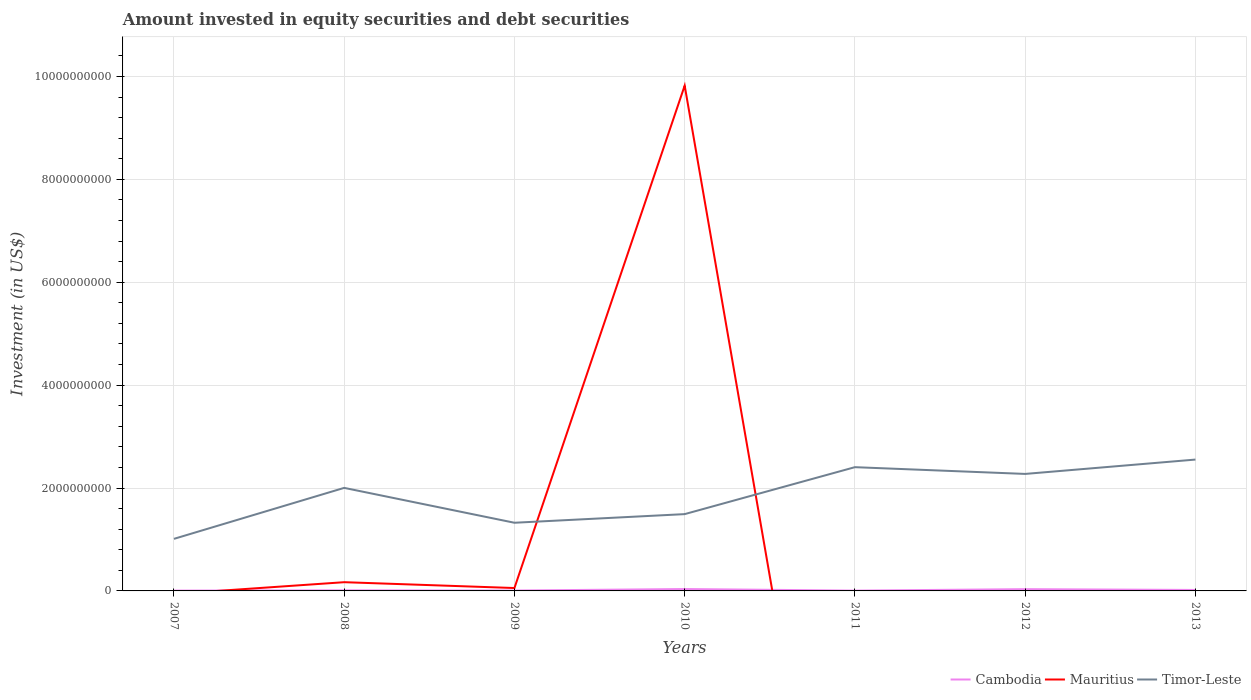Does the line corresponding to Mauritius intersect with the line corresponding to Timor-Leste?
Keep it short and to the point. Yes. Is the number of lines equal to the number of legend labels?
Ensure brevity in your answer.  No. What is the total amount invested in equity securities and debt securities in Mauritius in the graph?
Offer a very short reply. 1.13e+08. What is the difference between the highest and the second highest amount invested in equity securities and debt securities in Cambodia?
Make the answer very short. 3.05e+07. What is the difference between the highest and the lowest amount invested in equity securities and debt securities in Cambodia?
Provide a succinct answer. 3. Is the amount invested in equity securities and debt securities in Timor-Leste strictly greater than the amount invested in equity securities and debt securities in Cambodia over the years?
Your answer should be compact. No. How many lines are there?
Give a very brief answer. 3. How many years are there in the graph?
Your answer should be very brief. 7. Are the values on the major ticks of Y-axis written in scientific E-notation?
Make the answer very short. No. Where does the legend appear in the graph?
Make the answer very short. Bottom right. How many legend labels are there?
Your answer should be compact. 3. How are the legend labels stacked?
Provide a short and direct response. Horizontal. What is the title of the graph?
Your answer should be compact. Amount invested in equity securities and debt securities. What is the label or title of the X-axis?
Give a very brief answer. Years. What is the label or title of the Y-axis?
Provide a short and direct response. Investment (in US$). What is the Investment (in US$) of Cambodia in 2007?
Offer a terse response. 6.33e+06. What is the Investment (in US$) of Timor-Leste in 2007?
Offer a very short reply. 1.01e+09. What is the Investment (in US$) in Cambodia in 2008?
Provide a short and direct response. 1.16e+07. What is the Investment (in US$) of Mauritius in 2008?
Offer a very short reply. 1.70e+08. What is the Investment (in US$) in Timor-Leste in 2008?
Offer a very short reply. 2.00e+09. What is the Investment (in US$) in Cambodia in 2009?
Your answer should be very brief. 7.62e+06. What is the Investment (in US$) in Mauritius in 2009?
Offer a terse response. 5.63e+07. What is the Investment (in US$) in Timor-Leste in 2009?
Your answer should be compact. 1.33e+09. What is the Investment (in US$) in Cambodia in 2010?
Keep it short and to the point. 3.67e+07. What is the Investment (in US$) in Mauritius in 2010?
Your answer should be compact. 9.82e+09. What is the Investment (in US$) of Timor-Leste in 2010?
Ensure brevity in your answer.  1.49e+09. What is the Investment (in US$) in Cambodia in 2011?
Ensure brevity in your answer.  6.14e+06. What is the Investment (in US$) in Timor-Leste in 2011?
Offer a very short reply. 2.41e+09. What is the Investment (in US$) of Cambodia in 2012?
Ensure brevity in your answer.  3.42e+07. What is the Investment (in US$) of Mauritius in 2012?
Your answer should be very brief. 0. What is the Investment (in US$) in Timor-Leste in 2012?
Your answer should be very brief. 2.27e+09. What is the Investment (in US$) in Cambodia in 2013?
Make the answer very short. 1.88e+07. What is the Investment (in US$) of Timor-Leste in 2013?
Provide a succinct answer. 2.55e+09. Across all years, what is the maximum Investment (in US$) in Cambodia?
Your answer should be compact. 3.67e+07. Across all years, what is the maximum Investment (in US$) in Mauritius?
Provide a short and direct response. 9.82e+09. Across all years, what is the maximum Investment (in US$) in Timor-Leste?
Your answer should be very brief. 2.55e+09. Across all years, what is the minimum Investment (in US$) of Cambodia?
Ensure brevity in your answer.  6.14e+06. Across all years, what is the minimum Investment (in US$) of Mauritius?
Offer a very short reply. 0. Across all years, what is the minimum Investment (in US$) of Timor-Leste?
Give a very brief answer. 1.01e+09. What is the total Investment (in US$) of Cambodia in the graph?
Keep it short and to the point. 1.21e+08. What is the total Investment (in US$) of Mauritius in the graph?
Make the answer very short. 1.00e+1. What is the total Investment (in US$) in Timor-Leste in the graph?
Keep it short and to the point. 1.31e+1. What is the difference between the Investment (in US$) in Cambodia in 2007 and that in 2008?
Keep it short and to the point. -5.25e+06. What is the difference between the Investment (in US$) in Timor-Leste in 2007 and that in 2008?
Keep it short and to the point. -9.91e+08. What is the difference between the Investment (in US$) in Cambodia in 2007 and that in 2009?
Your answer should be very brief. -1.29e+06. What is the difference between the Investment (in US$) in Timor-Leste in 2007 and that in 2009?
Give a very brief answer. -3.13e+08. What is the difference between the Investment (in US$) of Cambodia in 2007 and that in 2010?
Offer a very short reply. -3.03e+07. What is the difference between the Investment (in US$) of Timor-Leste in 2007 and that in 2010?
Make the answer very short. -4.81e+08. What is the difference between the Investment (in US$) of Cambodia in 2007 and that in 2011?
Offer a terse response. 1.96e+05. What is the difference between the Investment (in US$) in Timor-Leste in 2007 and that in 2011?
Give a very brief answer. -1.39e+09. What is the difference between the Investment (in US$) in Cambodia in 2007 and that in 2012?
Offer a terse response. -2.78e+07. What is the difference between the Investment (in US$) of Timor-Leste in 2007 and that in 2012?
Ensure brevity in your answer.  -1.26e+09. What is the difference between the Investment (in US$) of Cambodia in 2007 and that in 2013?
Make the answer very short. -1.25e+07. What is the difference between the Investment (in US$) of Timor-Leste in 2007 and that in 2013?
Ensure brevity in your answer.  -1.54e+09. What is the difference between the Investment (in US$) of Cambodia in 2008 and that in 2009?
Make the answer very short. 3.97e+06. What is the difference between the Investment (in US$) in Mauritius in 2008 and that in 2009?
Give a very brief answer. 1.13e+08. What is the difference between the Investment (in US$) of Timor-Leste in 2008 and that in 2009?
Provide a succinct answer. 6.78e+08. What is the difference between the Investment (in US$) of Cambodia in 2008 and that in 2010?
Keep it short and to the point. -2.51e+07. What is the difference between the Investment (in US$) of Mauritius in 2008 and that in 2010?
Offer a terse response. -9.65e+09. What is the difference between the Investment (in US$) of Timor-Leste in 2008 and that in 2010?
Ensure brevity in your answer.  5.10e+08. What is the difference between the Investment (in US$) of Cambodia in 2008 and that in 2011?
Give a very brief answer. 5.45e+06. What is the difference between the Investment (in US$) in Timor-Leste in 2008 and that in 2011?
Provide a succinct answer. -4.03e+08. What is the difference between the Investment (in US$) in Cambodia in 2008 and that in 2012?
Provide a short and direct response. -2.26e+07. What is the difference between the Investment (in US$) in Timor-Leste in 2008 and that in 2012?
Keep it short and to the point. -2.71e+08. What is the difference between the Investment (in US$) of Cambodia in 2008 and that in 2013?
Make the answer very short. -7.21e+06. What is the difference between the Investment (in US$) of Timor-Leste in 2008 and that in 2013?
Offer a terse response. -5.50e+08. What is the difference between the Investment (in US$) in Cambodia in 2009 and that in 2010?
Your answer should be very brief. -2.90e+07. What is the difference between the Investment (in US$) of Mauritius in 2009 and that in 2010?
Give a very brief answer. -9.77e+09. What is the difference between the Investment (in US$) of Timor-Leste in 2009 and that in 2010?
Your answer should be very brief. -1.68e+08. What is the difference between the Investment (in US$) of Cambodia in 2009 and that in 2011?
Ensure brevity in your answer.  1.48e+06. What is the difference between the Investment (in US$) of Timor-Leste in 2009 and that in 2011?
Offer a very short reply. -1.08e+09. What is the difference between the Investment (in US$) in Cambodia in 2009 and that in 2012?
Make the answer very short. -2.66e+07. What is the difference between the Investment (in US$) of Timor-Leste in 2009 and that in 2012?
Offer a terse response. -9.49e+08. What is the difference between the Investment (in US$) in Cambodia in 2009 and that in 2013?
Give a very brief answer. -1.12e+07. What is the difference between the Investment (in US$) in Timor-Leste in 2009 and that in 2013?
Your answer should be very brief. -1.23e+09. What is the difference between the Investment (in US$) in Cambodia in 2010 and that in 2011?
Your answer should be compact. 3.05e+07. What is the difference between the Investment (in US$) of Timor-Leste in 2010 and that in 2011?
Ensure brevity in your answer.  -9.13e+08. What is the difference between the Investment (in US$) in Cambodia in 2010 and that in 2012?
Keep it short and to the point. 2.49e+06. What is the difference between the Investment (in US$) in Timor-Leste in 2010 and that in 2012?
Your answer should be very brief. -7.81e+08. What is the difference between the Investment (in US$) in Cambodia in 2010 and that in 2013?
Ensure brevity in your answer.  1.79e+07. What is the difference between the Investment (in US$) of Timor-Leste in 2010 and that in 2013?
Ensure brevity in your answer.  -1.06e+09. What is the difference between the Investment (in US$) in Cambodia in 2011 and that in 2012?
Provide a short and direct response. -2.80e+07. What is the difference between the Investment (in US$) of Timor-Leste in 2011 and that in 2012?
Offer a very short reply. 1.31e+08. What is the difference between the Investment (in US$) of Cambodia in 2011 and that in 2013?
Your answer should be very brief. -1.27e+07. What is the difference between the Investment (in US$) in Timor-Leste in 2011 and that in 2013?
Ensure brevity in your answer.  -1.48e+08. What is the difference between the Investment (in US$) in Cambodia in 2012 and that in 2013?
Your answer should be compact. 1.54e+07. What is the difference between the Investment (in US$) of Timor-Leste in 2012 and that in 2013?
Offer a terse response. -2.79e+08. What is the difference between the Investment (in US$) in Cambodia in 2007 and the Investment (in US$) in Mauritius in 2008?
Make the answer very short. -1.63e+08. What is the difference between the Investment (in US$) in Cambodia in 2007 and the Investment (in US$) in Timor-Leste in 2008?
Ensure brevity in your answer.  -2.00e+09. What is the difference between the Investment (in US$) in Cambodia in 2007 and the Investment (in US$) in Mauritius in 2009?
Provide a short and direct response. -5.00e+07. What is the difference between the Investment (in US$) in Cambodia in 2007 and the Investment (in US$) in Timor-Leste in 2009?
Provide a succinct answer. -1.32e+09. What is the difference between the Investment (in US$) in Cambodia in 2007 and the Investment (in US$) in Mauritius in 2010?
Make the answer very short. -9.82e+09. What is the difference between the Investment (in US$) in Cambodia in 2007 and the Investment (in US$) in Timor-Leste in 2010?
Offer a very short reply. -1.49e+09. What is the difference between the Investment (in US$) in Cambodia in 2007 and the Investment (in US$) in Timor-Leste in 2011?
Your answer should be very brief. -2.40e+09. What is the difference between the Investment (in US$) of Cambodia in 2007 and the Investment (in US$) of Timor-Leste in 2012?
Keep it short and to the point. -2.27e+09. What is the difference between the Investment (in US$) of Cambodia in 2007 and the Investment (in US$) of Timor-Leste in 2013?
Offer a terse response. -2.55e+09. What is the difference between the Investment (in US$) of Cambodia in 2008 and the Investment (in US$) of Mauritius in 2009?
Ensure brevity in your answer.  -4.47e+07. What is the difference between the Investment (in US$) of Cambodia in 2008 and the Investment (in US$) of Timor-Leste in 2009?
Offer a terse response. -1.31e+09. What is the difference between the Investment (in US$) in Mauritius in 2008 and the Investment (in US$) in Timor-Leste in 2009?
Give a very brief answer. -1.16e+09. What is the difference between the Investment (in US$) in Cambodia in 2008 and the Investment (in US$) in Mauritius in 2010?
Your answer should be compact. -9.81e+09. What is the difference between the Investment (in US$) in Cambodia in 2008 and the Investment (in US$) in Timor-Leste in 2010?
Ensure brevity in your answer.  -1.48e+09. What is the difference between the Investment (in US$) in Mauritius in 2008 and the Investment (in US$) in Timor-Leste in 2010?
Ensure brevity in your answer.  -1.32e+09. What is the difference between the Investment (in US$) of Cambodia in 2008 and the Investment (in US$) of Timor-Leste in 2011?
Keep it short and to the point. -2.39e+09. What is the difference between the Investment (in US$) in Mauritius in 2008 and the Investment (in US$) in Timor-Leste in 2011?
Offer a very short reply. -2.24e+09. What is the difference between the Investment (in US$) in Cambodia in 2008 and the Investment (in US$) in Timor-Leste in 2012?
Ensure brevity in your answer.  -2.26e+09. What is the difference between the Investment (in US$) of Mauritius in 2008 and the Investment (in US$) of Timor-Leste in 2012?
Offer a terse response. -2.10e+09. What is the difference between the Investment (in US$) in Cambodia in 2008 and the Investment (in US$) in Timor-Leste in 2013?
Offer a terse response. -2.54e+09. What is the difference between the Investment (in US$) in Mauritius in 2008 and the Investment (in US$) in Timor-Leste in 2013?
Offer a terse response. -2.38e+09. What is the difference between the Investment (in US$) in Cambodia in 2009 and the Investment (in US$) in Mauritius in 2010?
Offer a very short reply. -9.81e+09. What is the difference between the Investment (in US$) of Cambodia in 2009 and the Investment (in US$) of Timor-Leste in 2010?
Keep it short and to the point. -1.49e+09. What is the difference between the Investment (in US$) in Mauritius in 2009 and the Investment (in US$) in Timor-Leste in 2010?
Offer a terse response. -1.44e+09. What is the difference between the Investment (in US$) in Cambodia in 2009 and the Investment (in US$) in Timor-Leste in 2011?
Provide a short and direct response. -2.40e+09. What is the difference between the Investment (in US$) of Mauritius in 2009 and the Investment (in US$) of Timor-Leste in 2011?
Provide a short and direct response. -2.35e+09. What is the difference between the Investment (in US$) of Cambodia in 2009 and the Investment (in US$) of Timor-Leste in 2012?
Ensure brevity in your answer.  -2.27e+09. What is the difference between the Investment (in US$) in Mauritius in 2009 and the Investment (in US$) in Timor-Leste in 2012?
Offer a very short reply. -2.22e+09. What is the difference between the Investment (in US$) in Cambodia in 2009 and the Investment (in US$) in Timor-Leste in 2013?
Offer a terse response. -2.55e+09. What is the difference between the Investment (in US$) in Mauritius in 2009 and the Investment (in US$) in Timor-Leste in 2013?
Provide a succinct answer. -2.50e+09. What is the difference between the Investment (in US$) of Cambodia in 2010 and the Investment (in US$) of Timor-Leste in 2011?
Offer a very short reply. -2.37e+09. What is the difference between the Investment (in US$) in Mauritius in 2010 and the Investment (in US$) in Timor-Leste in 2011?
Offer a terse response. 7.42e+09. What is the difference between the Investment (in US$) of Cambodia in 2010 and the Investment (in US$) of Timor-Leste in 2012?
Provide a short and direct response. -2.24e+09. What is the difference between the Investment (in US$) in Mauritius in 2010 and the Investment (in US$) in Timor-Leste in 2012?
Give a very brief answer. 7.55e+09. What is the difference between the Investment (in US$) in Cambodia in 2010 and the Investment (in US$) in Timor-Leste in 2013?
Keep it short and to the point. -2.52e+09. What is the difference between the Investment (in US$) of Mauritius in 2010 and the Investment (in US$) of Timor-Leste in 2013?
Give a very brief answer. 7.27e+09. What is the difference between the Investment (in US$) of Cambodia in 2011 and the Investment (in US$) of Timor-Leste in 2012?
Offer a terse response. -2.27e+09. What is the difference between the Investment (in US$) of Cambodia in 2011 and the Investment (in US$) of Timor-Leste in 2013?
Ensure brevity in your answer.  -2.55e+09. What is the difference between the Investment (in US$) of Cambodia in 2012 and the Investment (in US$) of Timor-Leste in 2013?
Your answer should be very brief. -2.52e+09. What is the average Investment (in US$) in Cambodia per year?
Offer a very short reply. 1.73e+07. What is the average Investment (in US$) of Mauritius per year?
Provide a short and direct response. 1.44e+09. What is the average Investment (in US$) in Timor-Leste per year?
Ensure brevity in your answer.  1.87e+09. In the year 2007, what is the difference between the Investment (in US$) in Cambodia and Investment (in US$) in Timor-Leste?
Ensure brevity in your answer.  -1.01e+09. In the year 2008, what is the difference between the Investment (in US$) of Cambodia and Investment (in US$) of Mauritius?
Provide a short and direct response. -1.58e+08. In the year 2008, what is the difference between the Investment (in US$) in Cambodia and Investment (in US$) in Timor-Leste?
Provide a short and direct response. -1.99e+09. In the year 2008, what is the difference between the Investment (in US$) of Mauritius and Investment (in US$) of Timor-Leste?
Provide a short and direct response. -1.83e+09. In the year 2009, what is the difference between the Investment (in US$) in Cambodia and Investment (in US$) in Mauritius?
Make the answer very short. -4.87e+07. In the year 2009, what is the difference between the Investment (in US$) of Cambodia and Investment (in US$) of Timor-Leste?
Your answer should be very brief. -1.32e+09. In the year 2009, what is the difference between the Investment (in US$) in Mauritius and Investment (in US$) in Timor-Leste?
Give a very brief answer. -1.27e+09. In the year 2010, what is the difference between the Investment (in US$) of Cambodia and Investment (in US$) of Mauritius?
Keep it short and to the point. -9.79e+09. In the year 2010, what is the difference between the Investment (in US$) of Cambodia and Investment (in US$) of Timor-Leste?
Provide a succinct answer. -1.46e+09. In the year 2010, what is the difference between the Investment (in US$) in Mauritius and Investment (in US$) in Timor-Leste?
Give a very brief answer. 8.33e+09. In the year 2011, what is the difference between the Investment (in US$) of Cambodia and Investment (in US$) of Timor-Leste?
Ensure brevity in your answer.  -2.40e+09. In the year 2012, what is the difference between the Investment (in US$) in Cambodia and Investment (in US$) in Timor-Leste?
Offer a very short reply. -2.24e+09. In the year 2013, what is the difference between the Investment (in US$) in Cambodia and Investment (in US$) in Timor-Leste?
Keep it short and to the point. -2.53e+09. What is the ratio of the Investment (in US$) of Cambodia in 2007 to that in 2008?
Offer a very short reply. 0.55. What is the ratio of the Investment (in US$) in Timor-Leste in 2007 to that in 2008?
Provide a short and direct response. 0.51. What is the ratio of the Investment (in US$) of Cambodia in 2007 to that in 2009?
Offer a terse response. 0.83. What is the ratio of the Investment (in US$) in Timor-Leste in 2007 to that in 2009?
Keep it short and to the point. 0.76. What is the ratio of the Investment (in US$) of Cambodia in 2007 to that in 2010?
Offer a terse response. 0.17. What is the ratio of the Investment (in US$) in Timor-Leste in 2007 to that in 2010?
Offer a very short reply. 0.68. What is the ratio of the Investment (in US$) in Cambodia in 2007 to that in 2011?
Your answer should be very brief. 1.03. What is the ratio of the Investment (in US$) of Timor-Leste in 2007 to that in 2011?
Your answer should be compact. 0.42. What is the ratio of the Investment (in US$) of Cambodia in 2007 to that in 2012?
Make the answer very short. 0.19. What is the ratio of the Investment (in US$) in Timor-Leste in 2007 to that in 2012?
Keep it short and to the point. 0.45. What is the ratio of the Investment (in US$) of Cambodia in 2007 to that in 2013?
Provide a short and direct response. 0.34. What is the ratio of the Investment (in US$) of Timor-Leste in 2007 to that in 2013?
Keep it short and to the point. 0.4. What is the ratio of the Investment (in US$) in Cambodia in 2008 to that in 2009?
Offer a terse response. 1.52. What is the ratio of the Investment (in US$) of Mauritius in 2008 to that in 2009?
Provide a short and direct response. 3.01. What is the ratio of the Investment (in US$) of Timor-Leste in 2008 to that in 2009?
Give a very brief answer. 1.51. What is the ratio of the Investment (in US$) in Cambodia in 2008 to that in 2010?
Provide a short and direct response. 0.32. What is the ratio of the Investment (in US$) in Mauritius in 2008 to that in 2010?
Provide a short and direct response. 0.02. What is the ratio of the Investment (in US$) of Timor-Leste in 2008 to that in 2010?
Ensure brevity in your answer.  1.34. What is the ratio of the Investment (in US$) of Cambodia in 2008 to that in 2011?
Provide a succinct answer. 1.89. What is the ratio of the Investment (in US$) of Timor-Leste in 2008 to that in 2011?
Your answer should be compact. 0.83. What is the ratio of the Investment (in US$) of Cambodia in 2008 to that in 2012?
Offer a terse response. 0.34. What is the ratio of the Investment (in US$) in Timor-Leste in 2008 to that in 2012?
Make the answer very short. 0.88. What is the ratio of the Investment (in US$) in Cambodia in 2008 to that in 2013?
Offer a very short reply. 0.62. What is the ratio of the Investment (in US$) of Timor-Leste in 2008 to that in 2013?
Your answer should be compact. 0.78. What is the ratio of the Investment (in US$) in Cambodia in 2009 to that in 2010?
Make the answer very short. 0.21. What is the ratio of the Investment (in US$) of Mauritius in 2009 to that in 2010?
Your answer should be compact. 0.01. What is the ratio of the Investment (in US$) in Timor-Leste in 2009 to that in 2010?
Offer a terse response. 0.89. What is the ratio of the Investment (in US$) in Cambodia in 2009 to that in 2011?
Ensure brevity in your answer.  1.24. What is the ratio of the Investment (in US$) in Timor-Leste in 2009 to that in 2011?
Offer a very short reply. 0.55. What is the ratio of the Investment (in US$) of Cambodia in 2009 to that in 2012?
Keep it short and to the point. 0.22. What is the ratio of the Investment (in US$) in Timor-Leste in 2009 to that in 2012?
Keep it short and to the point. 0.58. What is the ratio of the Investment (in US$) in Cambodia in 2009 to that in 2013?
Provide a short and direct response. 0.41. What is the ratio of the Investment (in US$) in Timor-Leste in 2009 to that in 2013?
Ensure brevity in your answer.  0.52. What is the ratio of the Investment (in US$) of Cambodia in 2010 to that in 2011?
Make the answer very short. 5.97. What is the ratio of the Investment (in US$) of Timor-Leste in 2010 to that in 2011?
Give a very brief answer. 0.62. What is the ratio of the Investment (in US$) in Cambodia in 2010 to that in 2012?
Your answer should be compact. 1.07. What is the ratio of the Investment (in US$) in Timor-Leste in 2010 to that in 2012?
Provide a short and direct response. 0.66. What is the ratio of the Investment (in US$) of Cambodia in 2010 to that in 2013?
Provide a succinct answer. 1.95. What is the ratio of the Investment (in US$) in Timor-Leste in 2010 to that in 2013?
Provide a succinct answer. 0.58. What is the ratio of the Investment (in US$) in Cambodia in 2011 to that in 2012?
Ensure brevity in your answer.  0.18. What is the ratio of the Investment (in US$) of Timor-Leste in 2011 to that in 2012?
Provide a short and direct response. 1.06. What is the ratio of the Investment (in US$) in Cambodia in 2011 to that in 2013?
Offer a very short reply. 0.33. What is the ratio of the Investment (in US$) in Timor-Leste in 2011 to that in 2013?
Your response must be concise. 0.94. What is the ratio of the Investment (in US$) in Cambodia in 2012 to that in 2013?
Make the answer very short. 1.82. What is the ratio of the Investment (in US$) in Timor-Leste in 2012 to that in 2013?
Ensure brevity in your answer.  0.89. What is the difference between the highest and the second highest Investment (in US$) in Cambodia?
Your response must be concise. 2.49e+06. What is the difference between the highest and the second highest Investment (in US$) of Mauritius?
Offer a very short reply. 9.65e+09. What is the difference between the highest and the second highest Investment (in US$) of Timor-Leste?
Your answer should be compact. 1.48e+08. What is the difference between the highest and the lowest Investment (in US$) of Cambodia?
Provide a short and direct response. 3.05e+07. What is the difference between the highest and the lowest Investment (in US$) of Mauritius?
Offer a very short reply. 9.82e+09. What is the difference between the highest and the lowest Investment (in US$) of Timor-Leste?
Make the answer very short. 1.54e+09. 